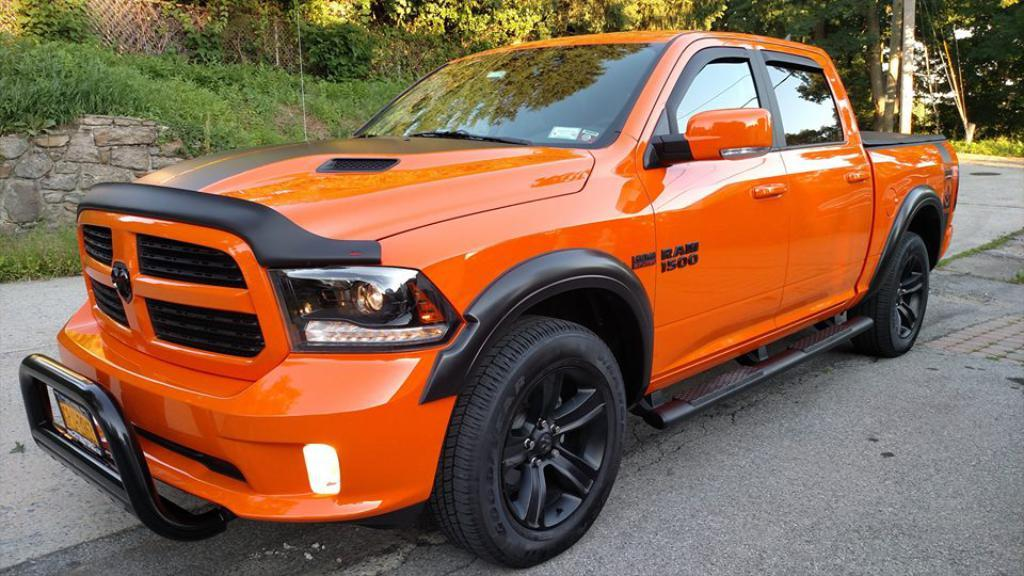What is on the road in the image? There is a vehicle on the road in the image. What can be seen in the background of the image? There are plants and trees in the background of the image. What type of cherries are being used to decorate the vehicle in the image? There are: There are no cherries present in the image, and the vehicle is not being decorated with them. 